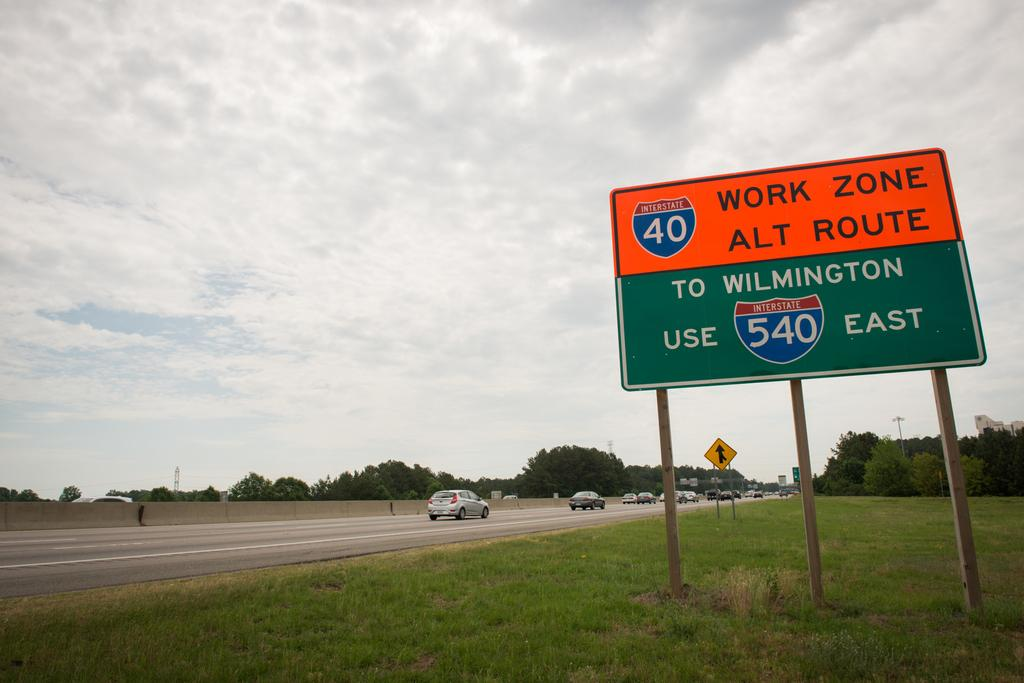<image>
Relay a brief, clear account of the picture shown. Orange and green sign on the highway going to Wilmington. 